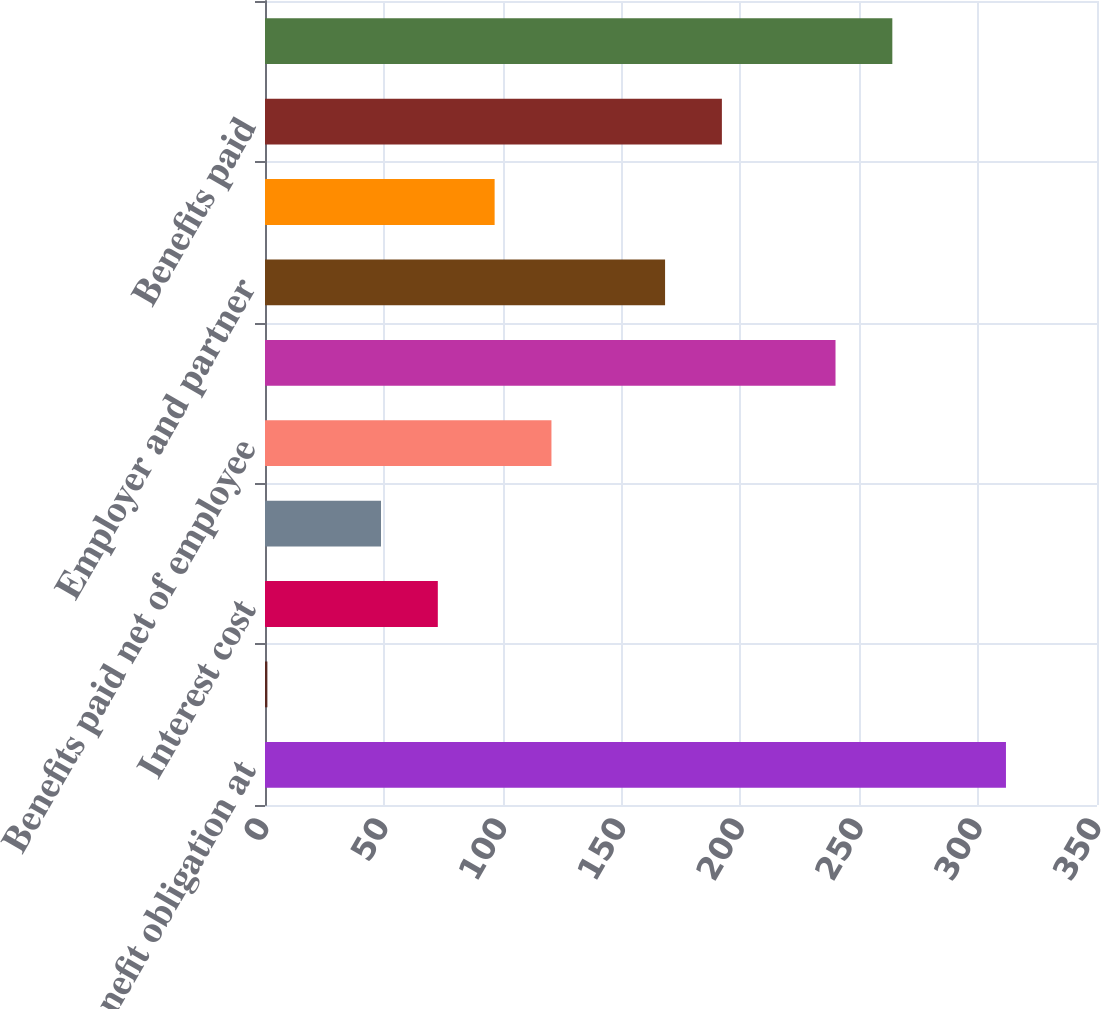Convert chart to OTSL. <chart><loc_0><loc_0><loc_500><loc_500><bar_chart><fcel>Benefit obligation at<fcel>Service cost<fcel>Interest cost<fcel>Actuarial losses (gains)<fcel>Benefits paid net of employee<fcel>Benefit obligation at end of<fcel>Employer and partner<fcel>Employee contributions<fcel>Benefits paid<fcel>Funded status<nl><fcel>311.7<fcel>1<fcel>72.7<fcel>48.8<fcel>120.5<fcel>240<fcel>168.3<fcel>96.6<fcel>192.2<fcel>263.9<nl></chart> 